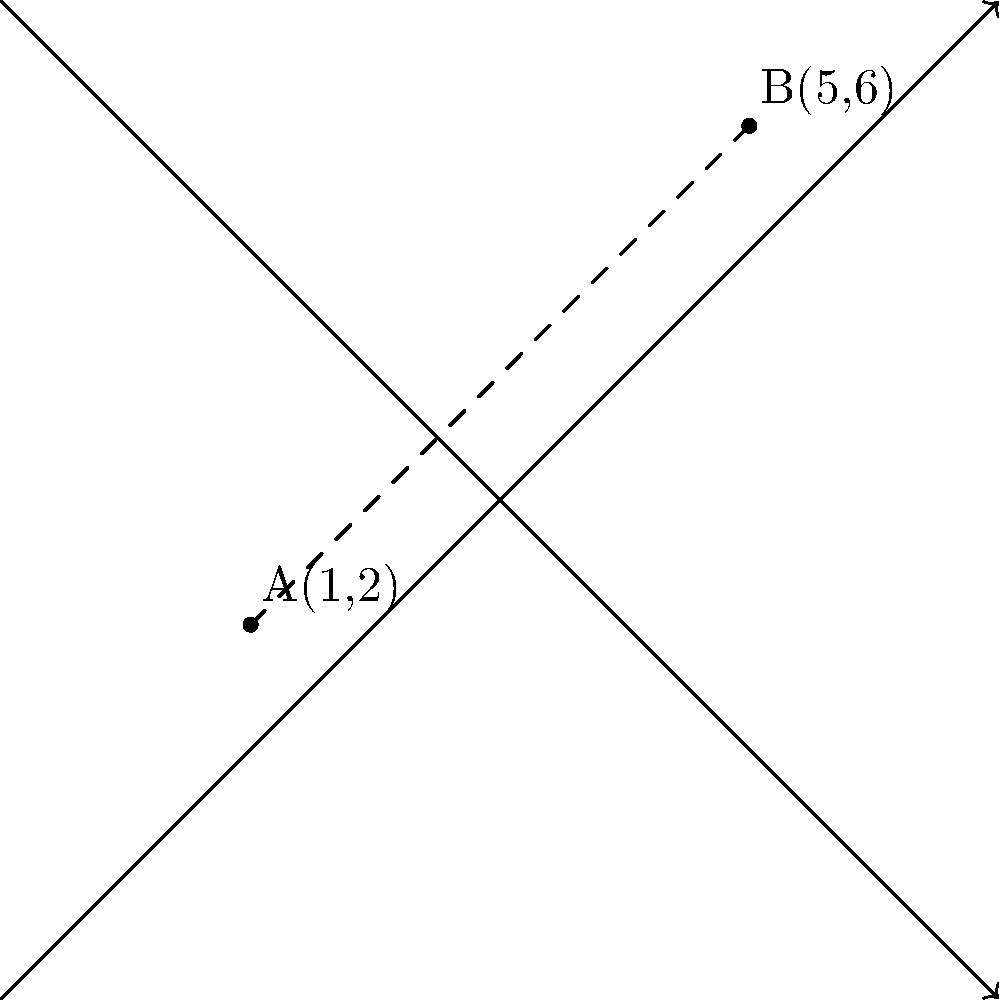During a live performance, you notice that the lead singer and the bassist are standing at different positions on the stage. If we represent the stage as a coordinate plane where the lead singer is at point A(1,2) and the bassist is at point B(5,6), calculate the distance between them. Round your answer to two decimal places. To find the distance between two points on a coordinate plane, we can use the distance formula:

$$d = \sqrt{(x_2-x_1)^2 + (y_2-y_1)^2}$$

Where $(x_1,y_1)$ represents the coordinates of the first point and $(x_2,y_2)$ represents the coordinates of the second point.

Let's plug in our values:
$(x_1,y_1) = (1,2)$ for point A (lead singer)
$(x_2,y_2) = (5,6)$ for point B (bassist)

Now, let's calculate:

1) First, find the differences:
   $x_2 - x_1 = 5 - 1 = 4$
   $y_2 - y_1 = 6 - 2 = 4$

2) Square these differences:
   $(x_2 - x_1)^2 = 4^2 = 16$
   $(y_2 - y_1)^2 = 4^2 = 16$

3) Add these squared differences:
   $16 + 16 = 32$

4) Take the square root:
   $d = \sqrt{32}$

5) Simplify:
   $d = 4\sqrt{2} \approx 5.66$

6) Rounding to two decimal places:
   $d \approx 5.66$

Therefore, the distance between the lead singer and the bassist is approximately 5.66 units.
Answer: 5.66 units 